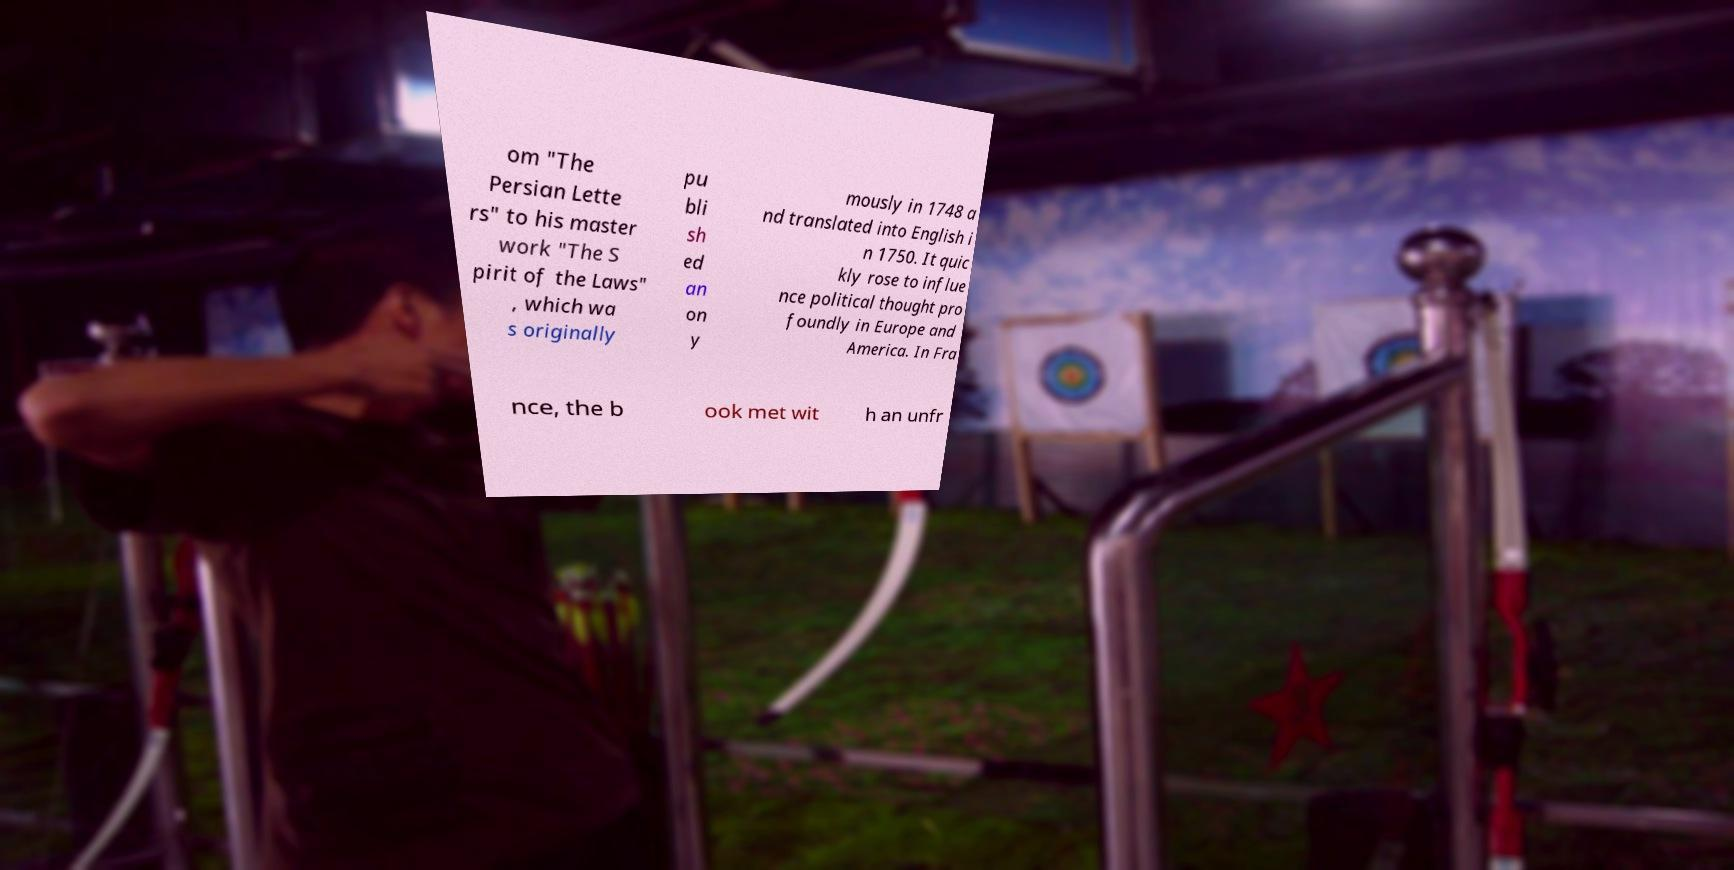Please read and relay the text visible in this image. What does it say? om "The Persian Lette rs" to his master work "The S pirit of the Laws" , which wa s originally pu bli sh ed an on y mously in 1748 a nd translated into English i n 1750. It quic kly rose to influe nce political thought pro foundly in Europe and America. In Fra nce, the b ook met wit h an unfr 